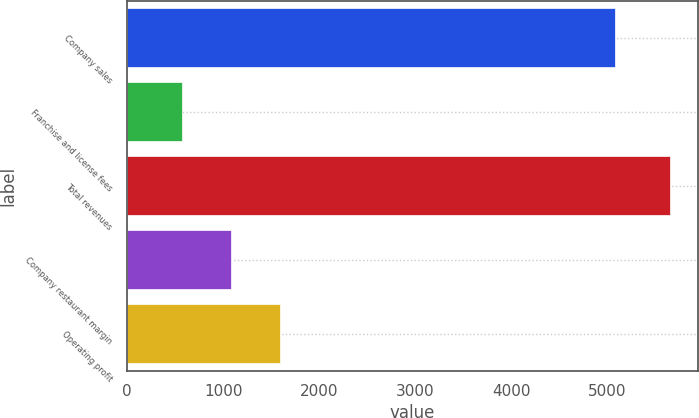Convert chart to OTSL. <chart><loc_0><loc_0><loc_500><loc_500><bar_chart><fcel>Company sales<fcel>Franchise and license fees<fcel>Total revenues<fcel>Company restaurant margin<fcel>Operating profit<nl><fcel>5081<fcel>574<fcel>5655<fcel>1082.1<fcel>1590.2<nl></chart> 